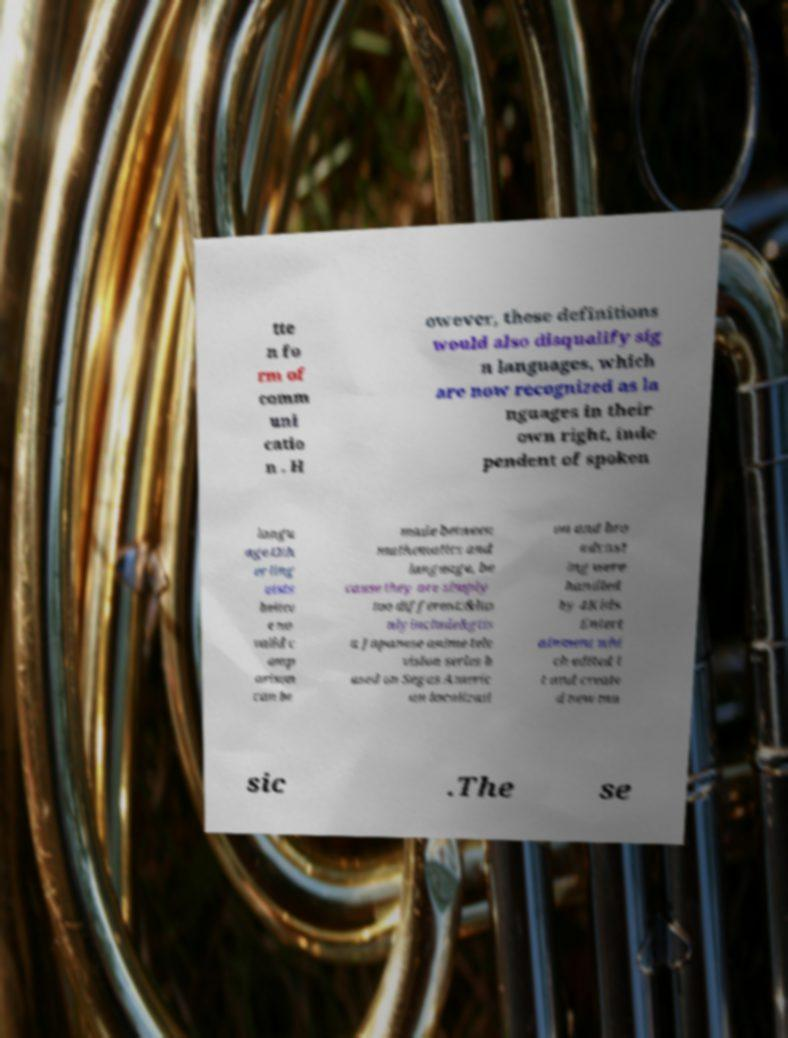I need the written content from this picture converted into text. Can you do that? tte n fo rm of comm uni catio n . H owever, these definitions would also disqualify sig n languages, which are now recognized as la nguages in their own right, inde pendent of spoken langu age.Oth er ling uists believ e no valid c omp arison can be made between mathematics and language, be cause they are simply too different:&lto nlyinclude&gtis a Japanese anime tele vision series b ased on Segas Americ an localizati on and bro adcast ing were handled by 4Kids Entert ainment whi ch edited i t and create d new mu sic .The se 